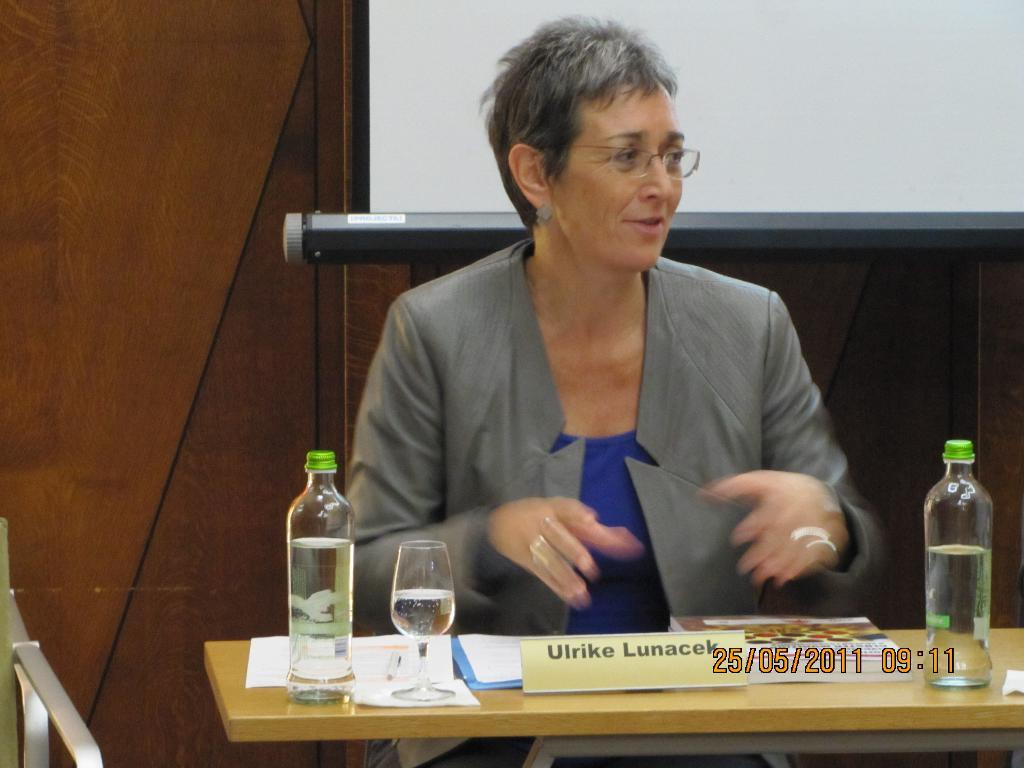Provide a one-sentence caption for the provided image. Ulrike Lunacek is shown at a podium or desk in a picture that is dated 25/05/2011. 